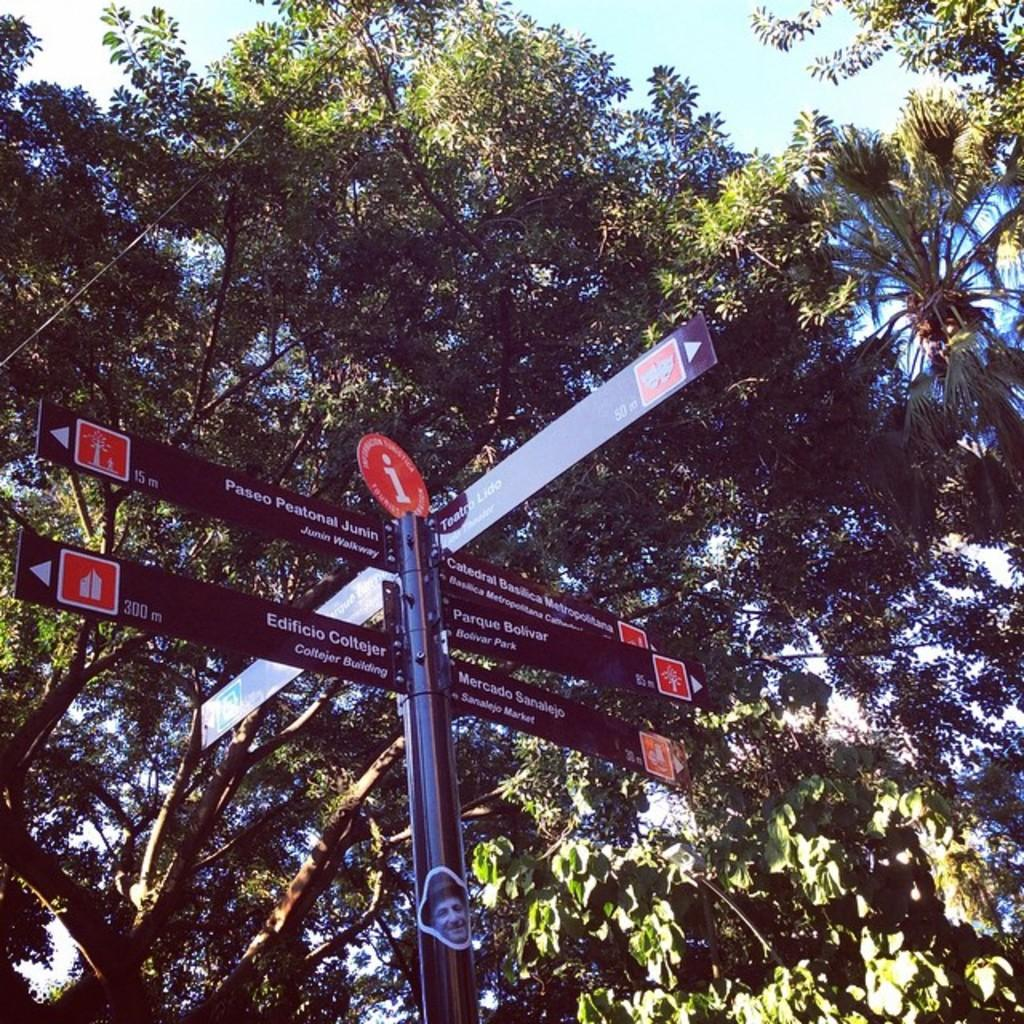What is located in the foreground of the image? There is a sign board in the foreground of the image. What can be seen in the background of the image? There are trees and the sky visible in the background of the image. What type of clock is hanging from the tree in the image? There is no clock present in the image; it only features a sign board, trees, and the sky. 